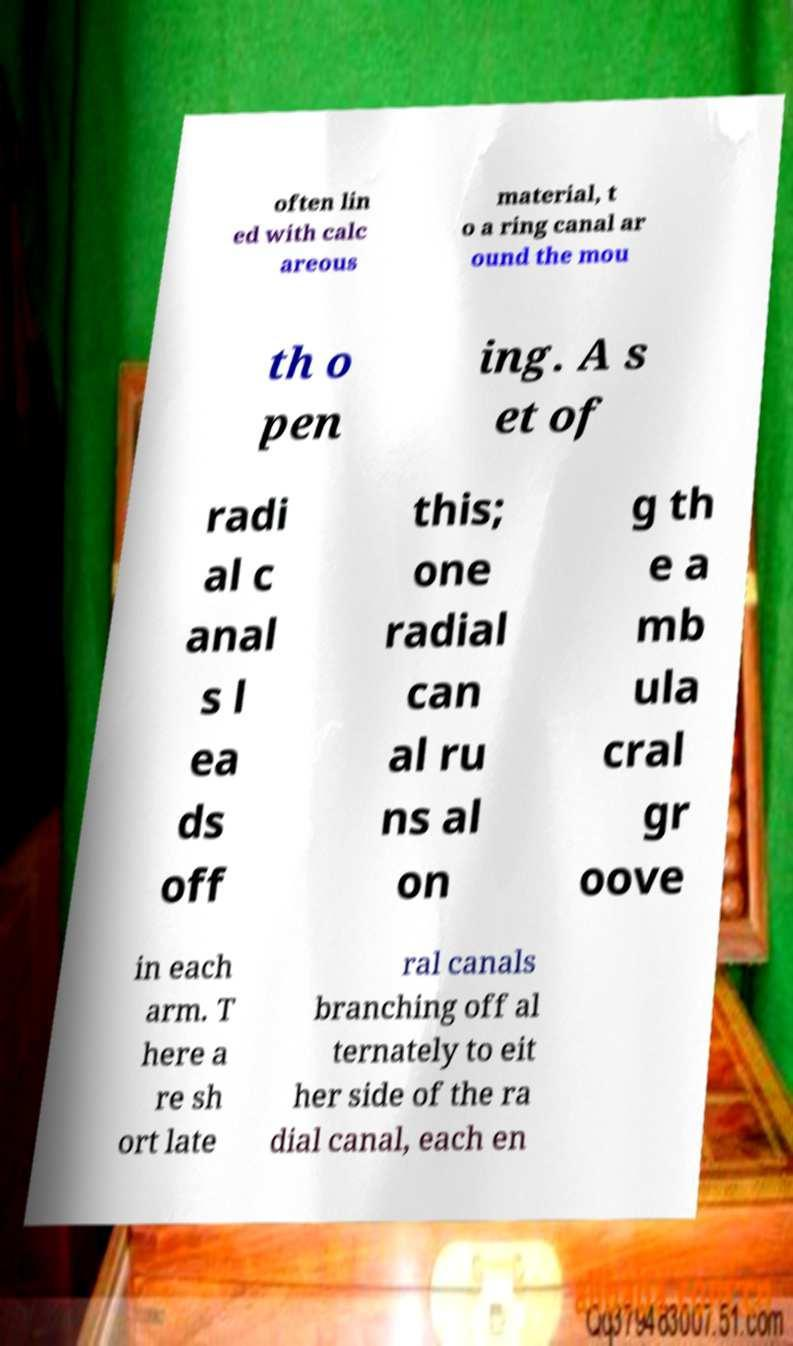I need the written content from this picture converted into text. Can you do that? often lin ed with calc areous material, t o a ring canal ar ound the mou th o pen ing. A s et of radi al c anal s l ea ds off this; one radial can al ru ns al on g th e a mb ula cral gr oove in each arm. T here a re sh ort late ral canals branching off al ternately to eit her side of the ra dial canal, each en 